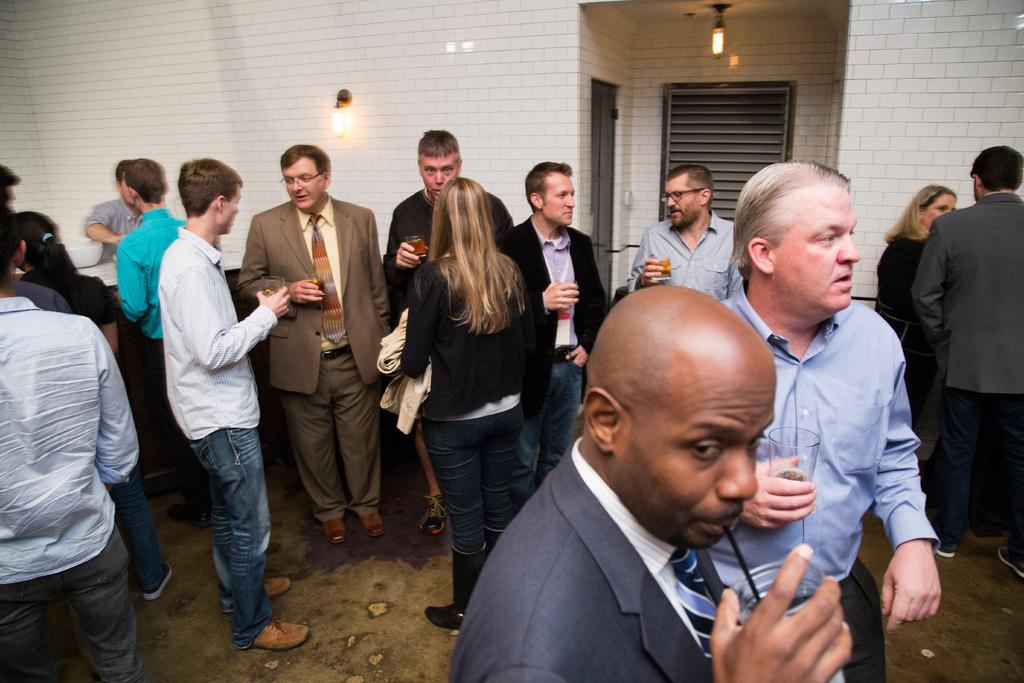How would you summarize this image in a sentence or two? In this picture I can see number of people who are standing and I see that most of them are holding glasses in their hands. In the background I can see the wall and I see the lights. 